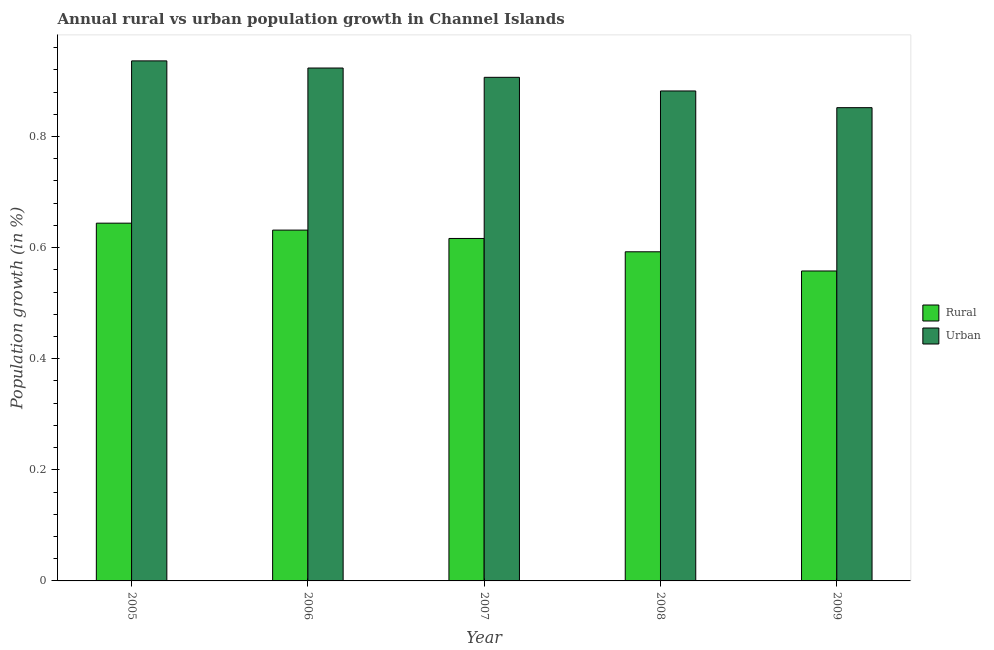How many different coloured bars are there?
Your answer should be compact. 2. Are the number of bars per tick equal to the number of legend labels?
Provide a short and direct response. Yes. Are the number of bars on each tick of the X-axis equal?
Make the answer very short. Yes. How many bars are there on the 4th tick from the left?
Offer a very short reply. 2. What is the label of the 2nd group of bars from the left?
Offer a terse response. 2006. What is the urban population growth in 2006?
Offer a terse response. 0.92. Across all years, what is the maximum urban population growth?
Your answer should be compact. 0.94. Across all years, what is the minimum rural population growth?
Ensure brevity in your answer.  0.56. In which year was the rural population growth maximum?
Your answer should be very brief. 2005. In which year was the urban population growth minimum?
Provide a succinct answer. 2009. What is the total rural population growth in the graph?
Ensure brevity in your answer.  3.04. What is the difference between the urban population growth in 2006 and that in 2008?
Offer a terse response. 0.04. What is the difference between the urban population growth in 2008 and the rural population growth in 2007?
Make the answer very short. -0.02. What is the average urban population growth per year?
Give a very brief answer. 0.9. What is the ratio of the rural population growth in 2005 to that in 2009?
Offer a terse response. 1.15. Is the urban population growth in 2006 less than that in 2007?
Your answer should be very brief. No. What is the difference between the highest and the second highest urban population growth?
Your answer should be compact. 0.01. What is the difference between the highest and the lowest rural population growth?
Keep it short and to the point. 0.09. In how many years, is the urban population growth greater than the average urban population growth taken over all years?
Make the answer very short. 3. What does the 1st bar from the left in 2008 represents?
Ensure brevity in your answer.  Rural. What does the 2nd bar from the right in 2008 represents?
Your response must be concise. Rural. How many bars are there?
Provide a short and direct response. 10. Does the graph contain any zero values?
Provide a succinct answer. No. Does the graph contain grids?
Your answer should be compact. No. Where does the legend appear in the graph?
Your response must be concise. Center right. How many legend labels are there?
Your answer should be compact. 2. How are the legend labels stacked?
Provide a succinct answer. Vertical. What is the title of the graph?
Provide a succinct answer. Annual rural vs urban population growth in Channel Islands. What is the label or title of the X-axis?
Keep it short and to the point. Year. What is the label or title of the Y-axis?
Provide a succinct answer. Population growth (in %). What is the Population growth (in %) in Rural in 2005?
Provide a short and direct response. 0.64. What is the Population growth (in %) of Urban  in 2005?
Offer a terse response. 0.94. What is the Population growth (in %) in Rural in 2006?
Provide a short and direct response. 0.63. What is the Population growth (in %) of Urban  in 2006?
Offer a terse response. 0.92. What is the Population growth (in %) in Rural in 2007?
Ensure brevity in your answer.  0.62. What is the Population growth (in %) of Urban  in 2007?
Your answer should be very brief. 0.91. What is the Population growth (in %) of Rural in 2008?
Offer a terse response. 0.59. What is the Population growth (in %) of Urban  in 2008?
Offer a terse response. 0.88. What is the Population growth (in %) of Rural in 2009?
Offer a terse response. 0.56. What is the Population growth (in %) in Urban  in 2009?
Give a very brief answer. 0.85. Across all years, what is the maximum Population growth (in %) in Rural?
Offer a very short reply. 0.64. Across all years, what is the maximum Population growth (in %) of Urban ?
Make the answer very short. 0.94. Across all years, what is the minimum Population growth (in %) in Rural?
Make the answer very short. 0.56. Across all years, what is the minimum Population growth (in %) in Urban ?
Your response must be concise. 0.85. What is the total Population growth (in %) in Rural in the graph?
Provide a succinct answer. 3.04. What is the total Population growth (in %) of Urban  in the graph?
Your answer should be very brief. 4.5. What is the difference between the Population growth (in %) in Rural in 2005 and that in 2006?
Offer a terse response. 0.01. What is the difference between the Population growth (in %) of Urban  in 2005 and that in 2006?
Offer a very short reply. 0.01. What is the difference between the Population growth (in %) in Rural in 2005 and that in 2007?
Give a very brief answer. 0.03. What is the difference between the Population growth (in %) in Urban  in 2005 and that in 2007?
Provide a succinct answer. 0.03. What is the difference between the Population growth (in %) in Rural in 2005 and that in 2008?
Provide a short and direct response. 0.05. What is the difference between the Population growth (in %) in Urban  in 2005 and that in 2008?
Keep it short and to the point. 0.05. What is the difference between the Population growth (in %) in Rural in 2005 and that in 2009?
Offer a terse response. 0.09. What is the difference between the Population growth (in %) in Urban  in 2005 and that in 2009?
Provide a short and direct response. 0.08. What is the difference between the Population growth (in %) of Rural in 2006 and that in 2007?
Your response must be concise. 0.02. What is the difference between the Population growth (in %) of Urban  in 2006 and that in 2007?
Your answer should be compact. 0.02. What is the difference between the Population growth (in %) in Rural in 2006 and that in 2008?
Give a very brief answer. 0.04. What is the difference between the Population growth (in %) in Urban  in 2006 and that in 2008?
Make the answer very short. 0.04. What is the difference between the Population growth (in %) in Rural in 2006 and that in 2009?
Provide a succinct answer. 0.07. What is the difference between the Population growth (in %) of Urban  in 2006 and that in 2009?
Make the answer very short. 0.07. What is the difference between the Population growth (in %) of Rural in 2007 and that in 2008?
Offer a terse response. 0.02. What is the difference between the Population growth (in %) in Urban  in 2007 and that in 2008?
Your response must be concise. 0.02. What is the difference between the Population growth (in %) in Rural in 2007 and that in 2009?
Provide a succinct answer. 0.06. What is the difference between the Population growth (in %) of Urban  in 2007 and that in 2009?
Offer a very short reply. 0.05. What is the difference between the Population growth (in %) of Rural in 2008 and that in 2009?
Provide a short and direct response. 0.03. What is the difference between the Population growth (in %) in Urban  in 2008 and that in 2009?
Offer a terse response. 0.03. What is the difference between the Population growth (in %) of Rural in 2005 and the Population growth (in %) of Urban  in 2006?
Give a very brief answer. -0.28. What is the difference between the Population growth (in %) of Rural in 2005 and the Population growth (in %) of Urban  in 2007?
Ensure brevity in your answer.  -0.26. What is the difference between the Population growth (in %) in Rural in 2005 and the Population growth (in %) in Urban  in 2008?
Keep it short and to the point. -0.24. What is the difference between the Population growth (in %) in Rural in 2005 and the Population growth (in %) in Urban  in 2009?
Keep it short and to the point. -0.21. What is the difference between the Population growth (in %) of Rural in 2006 and the Population growth (in %) of Urban  in 2007?
Provide a short and direct response. -0.28. What is the difference between the Population growth (in %) in Rural in 2006 and the Population growth (in %) in Urban  in 2008?
Keep it short and to the point. -0.25. What is the difference between the Population growth (in %) in Rural in 2006 and the Population growth (in %) in Urban  in 2009?
Ensure brevity in your answer.  -0.22. What is the difference between the Population growth (in %) in Rural in 2007 and the Population growth (in %) in Urban  in 2008?
Provide a short and direct response. -0.27. What is the difference between the Population growth (in %) in Rural in 2007 and the Population growth (in %) in Urban  in 2009?
Give a very brief answer. -0.24. What is the difference between the Population growth (in %) of Rural in 2008 and the Population growth (in %) of Urban  in 2009?
Give a very brief answer. -0.26. What is the average Population growth (in %) in Rural per year?
Your response must be concise. 0.61. What is the average Population growth (in %) in Urban  per year?
Keep it short and to the point. 0.9. In the year 2005, what is the difference between the Population growth (in %) of Rural and Population growth (in %) of Urban ?
Your answer should be compact. -0.29. In the year 2006, what is the difference between the Population growth (in %) in Rural and Population growth (in %) in Urban ?
Your response must be concise. -0.29. In the year 2007, what is the difference between the Population growth (in %) of Rural and Population growth (in %) of Urban ?
Give a very brief answer. -0.29. In the year 2008, what is the difference between the Population growth (in %) in Rural and Population growth (in %) in Urban ?
Offer a very short reply. -0.29. In the year 2009, what is the difference between the Population growth (in %) in Rural and Population growth (in %) in Urban ?
Your response must be concise. -0.29. What is the ratio of the Population growth (in %) of Rural in 2005 to that in 2006?
Your response must be concise. 1.02. What is the ratio of the Population growth (in %) in Urban  in 2005 to that in 2006?
Offer a very short reply. 1.01. What is the ratio of the Population growth (in %) of Rural in 2005 to that in 2007?
Your answer should be very brief. 1.04. What is the ratio of the Population growth (in %) of Urban  in 2005 to that in 2007?
Your answer should be compact. 1.03. What is the ratio of the Population growth (in %) in Rural in 2005 to that in 2008?
Your response must be concise. 1.09. What is the ratio of the Population growth (in %) in Urban  in 2005 to that in 2008?
Give a very brief answer. 1.06. What is the ratio of the Population growth (in %) of Rural in 2005 to that in 2009?
Your answer should be compact. 1.15. What is the ratio of the Population growth (in %) of Urban  in 2005 to that in 2009?
Offer a terse response. 1.1. What is the ratio of the Population growth (in %) in Rural in 2006 to that in 2007?
Provide a succinct answer. 1.02. What is the ratio of the Population growth (in %) in Urban  in 2006 to that in 2007?
Provide a short and direct response. 1.02. What is the ratio of the Population growth (in %) of Rural in 2006 to that in 2008?
Offer a very short reply. 1.07. What is the ratio of the Population growth (in %) of Urban  in 2006 to that in 2008?
Give a very brief answer. 1.05. What is the ratio of the Population growth (in %) in Rural in 2006 to that in 2009?
Give a very brief answer. 1.13. What is the ratio of the Population growth (in %) of Urban  in 2006 to that in 2009?
Keep it short and to the point. 1.08. What is the ratio of the Population growth (in %) of Rural in 2007 to that in 2008?
Offer a very short reply. 1.04. What is the ratio of the Population growth (in %) of Urban  in 2007 to that in 2008?
Provide a succinct answer. 1.03. What is the ratio of the Population growth (in %) in Rural in 2007 to that in 2009?
Ensure brevity in your answer.  1.1. What is the ratio of the Population growth (in %) in Urban  in 2007 to that in 2009?
Provide a succinct answer. 1.06. What is the ratio of the Population growth (in %) in Rural in 2008 to that in 2009?
Make the answer very short. 1.06. What is the ratio of the Population growth (in %) in Urban  in 2008 to that in 2009?
Offer a terse response. 1.04. What is the difference between the highest and the second highest Population growth (in %) of Rural?
Your answer should be very brief. 0.01. What is the difference between the highest and the second highest Population growth (in %) in Urban ?
Provide a succinct answer. 0.01. What is the difference between the highest and the lowest Population growth (in %) of Rural?
Give a very brief answer. 0.09. What is the difference between the highest and the lowest Population growth (in %) in Urban ?
Your response must be concise. 0.08. 